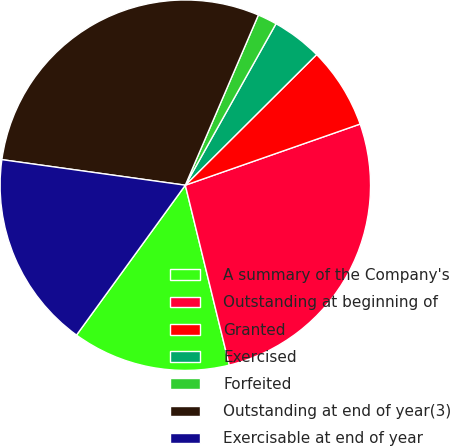Convert chart to OTSL. <chart><loc_0><loc_0><loc_500><loc_500><pie_chart><fcel>A summary of the Company's<fcel>Outstanding at beginning of<fcel>Granted<fcel>Exercised<fcel>Forfeited<fcel>Outstanding at end of year(3)<fcel>Exercisable at end of year<nl><fcel>13.81%<fcel>26.54%<fcel>7.1%<fcel>4.4%<fcel>1.69%<fcel>29.25%<fcel>17.21%<nl></chart> 